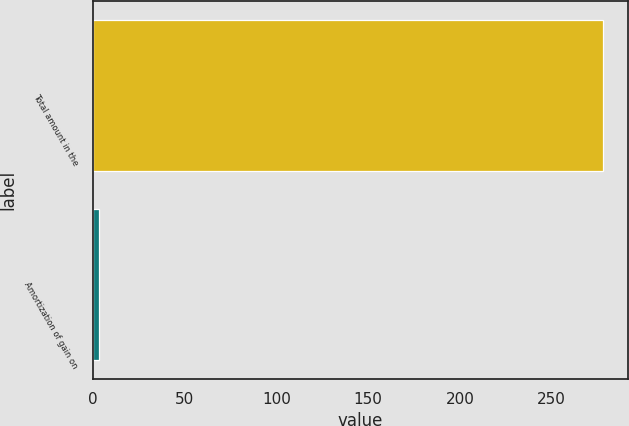Convert chart to OTSL. <chart><loc_0><loc_0><loc_500><loc_500><bar_chart><fcel>Total amount in the<fcel>Amortization of gain on<nl><fcel>277.9<fcel>3.2<nl></chart> 